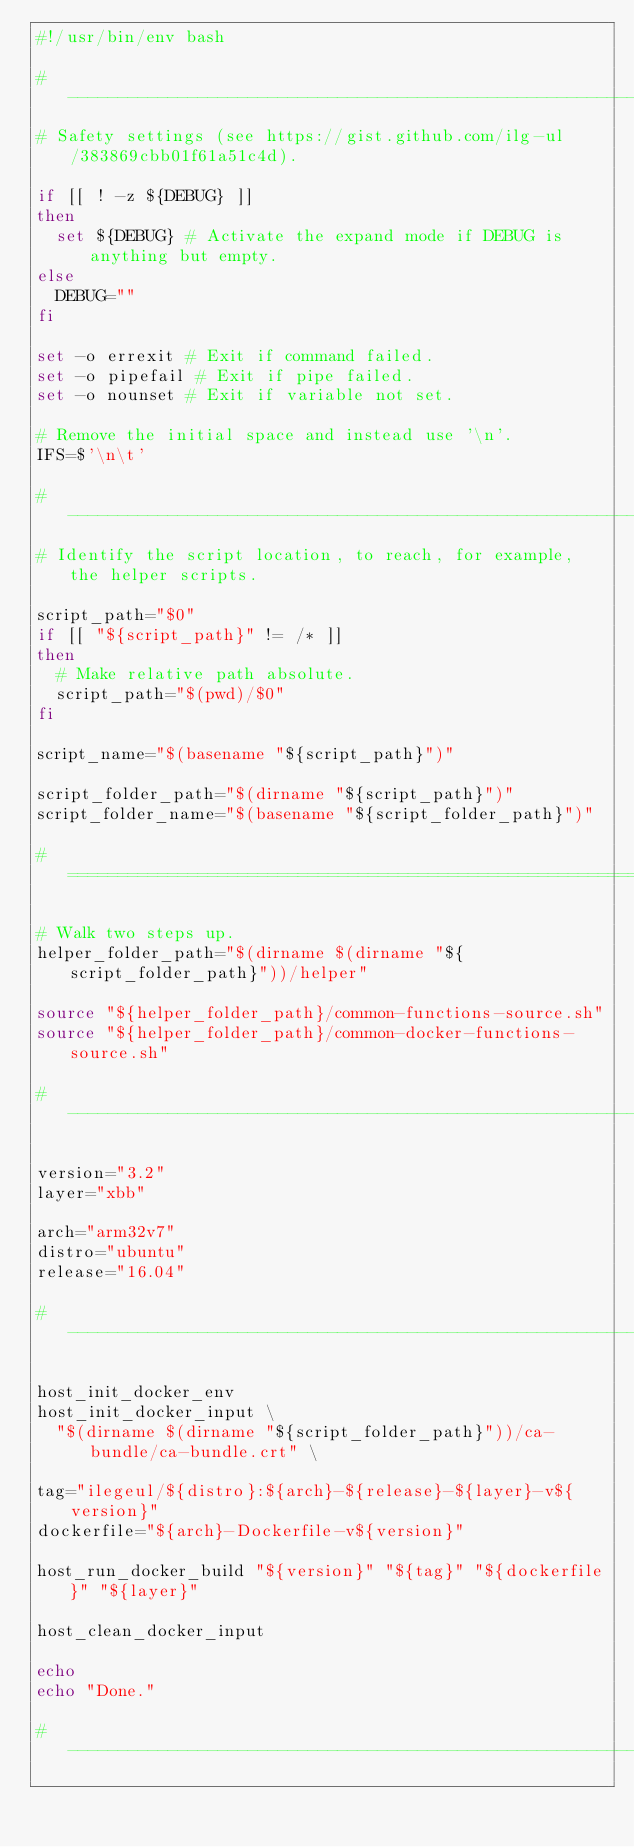<code> <loc_0><loc_0><loc_500><loc_500><_Bash_>#!/usr/bin/env bash

# -----------------------------------------------------------------------------
# Safety settings (see https://gist.github.com/ilg-ul/383869cbb01f61a51c4d).

if [[ ! -z ${DEBUG} ]]
then
  set ${DEBUG} # Activate the expand mode if DEBUG is anything but empty.
else
  DEBUG=""
fi

set -o errexit # Exit if command failed.
set -o pipefail # Exit if pipe failed.
set -o nounset # Exit if variable not set.

# Remove the initial space and instead use '\n'.
IFS=$'\n\t'

# -----------------------------------------------------------------------------
# Identify the script location, to reach, for example, the helper scripts.

script_path="$0"
if [[ "${script_path}" != /* ]]
then
  # Make relative path absolute.
  script_path="$(pwd)/$0"
fi

script_name="$(basename "${script_path}")"

script_folder_path="$(dirname "${script_path}")"
script_folder_name="$(basename "${script_folder_path}")"

# =============================================================================

# Walk two steps up.
helper_folder_path="$(dirname $(dirname "${script_folder_path}"))/helper"

source "${helper_folder_path}/common-functions-source.sh"
source "${helper_folder_path}/common-docker-functions-source.sh"

# -----------------------------------------------------------------------------

version="3.2"
layer="xbb"

arch="arm32v7"
distro="ubuntu"
release="16.04"

# -----------------------------------------------------------------------------

host_init_docker_env
host_init_docker_input \
  "$(dirname $(dirname "${script_folder_path}"))/ca-bundle/ca-bundle.crt" \

tag="ilegeul/${distro}:${arch}-${release}-${layer}-v${version}"
dockerfile="${arch}-Dockerfile-v${version}"

host_run_docker_build "${version}" "${tag}" "${dockerfile}" "${layer}"

host_clean_docker_input

echo 
echo "Done."

# -----------------------------------------------------------------------------
</code> 